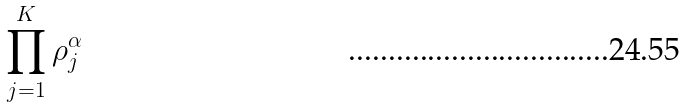Convert formula to latex. <formula><loc_0><loc_0><loc_500><loc_500>\prod _ { j = 1 } ^ { K } \rho _ { j } ^ { \alpha }</formula> 